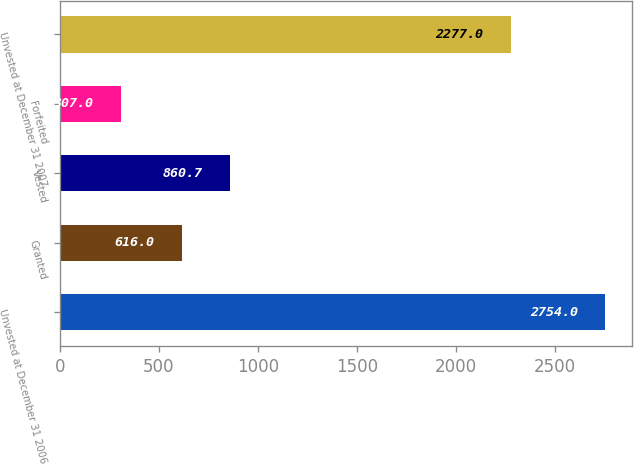<chart> <loc_0><loc_0><loc_500><loc_500><bar_chart><fcel>Unvested at December 31 2006<fcel>Granted<fcel>Vested<fcel>Forfeited<fcel>Unvested at December 31 2007<nl><fcel>2754<fcel>616<fcel>860.7<fcel>307<fcel>2277<nl></chart> 